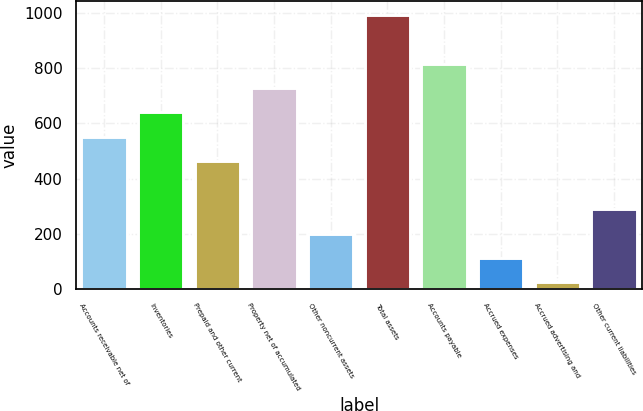<chart> <loc_0><loc_0><loc_500><loc_500><bar_chart><fcel>Accounts receivable net of<fcel>Inventories<fcel>Prepaid and other current<fcel>Property net of accumulated<fcel>Other noncurrent assets<fcel>Total assets<fcel>Accounts payable<fcel>Accrued expenses<fcel>Accrued advertising and<fcel>Other current liabilities<nl><fcel>552<fcel>640<fcel>464<fcel>728<fcel>200<fcel>992<fcel>816<fcel>112<fcel>24<fcel>288<nl></chart> 